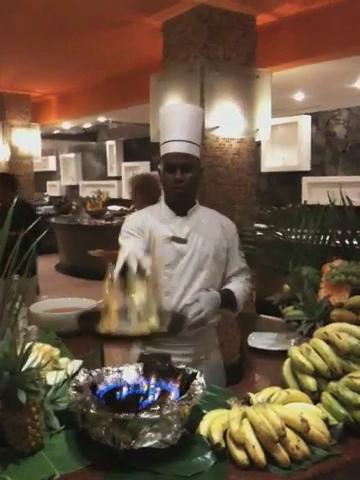What kind of fruit is on the counter?
Concise answer only. Banana. Is this a fancy restaurant?
Be succinct. Yes. What kind of job does this man hold?
Answer briefly. Chef. Is this a market?
Short answer required. No. 